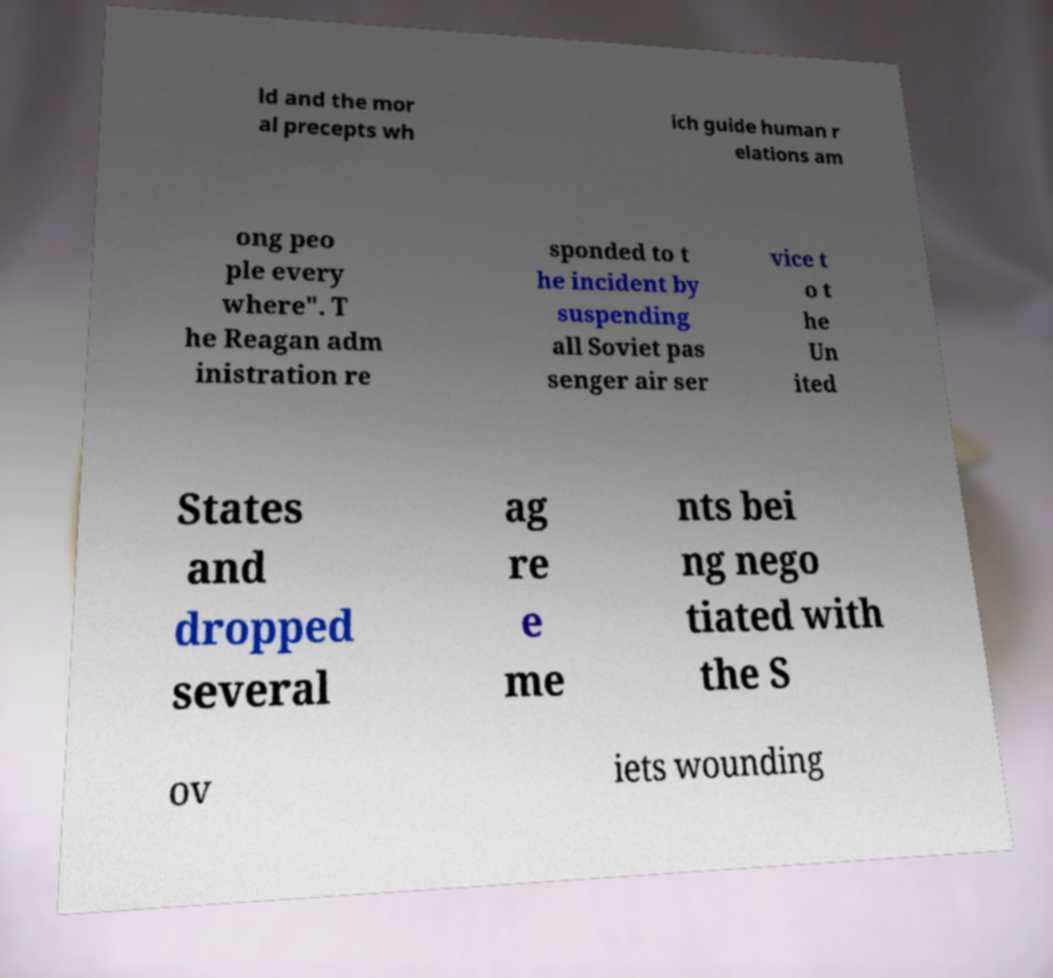What messages or text are displayed in this image? I need them in a readable, typed format. ld and the mor al precepts wh ich guide human r elations am ong peo ple every where". T he Reagan adm inistration re sponded to t he incident by suspending all Soviet pas senger air ser vice t o t he Un ited States and dropped several ag re e me nts bei ng nego tiated with the S ov iets wounding 